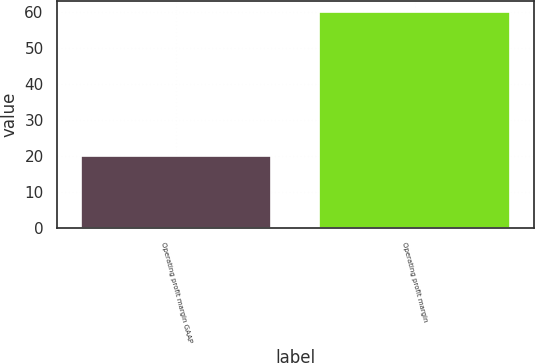Convert chart. <chart><loc_0><loc_0><loc_500><loc_500><bar_chart><fcel>Operating profit margin GAAP<fcel>Operating profit margin<nl><fcel>20<fcel>60<nl></chart> 